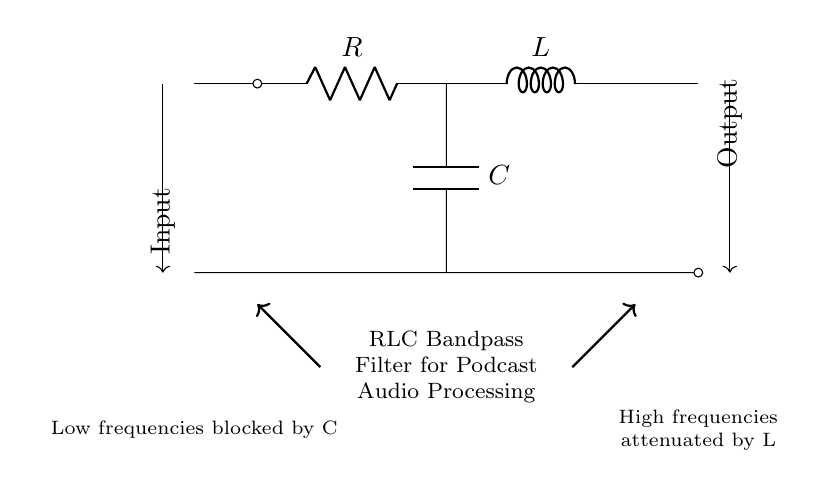What type of filter is represented in the circuit? The circuit diagram features an RLC bandpass filter, which is evident by the presence of a resistor, inductor, and capacitor connected in a specific arrangement designed to allow a certain range of frequencies to pass while attenuating others.
Answer: RLC bandpass filter What component blocks low frequencies? In the circuit, the capacitor is responsible for blocking low frequencies. Capacitors typically have lower impedance at higher frequencies, allowing them to pass higher frequency signals while filtering out lower frequencies.
Answer: Capacitor Which component is connected in series with the input? The resistor is the first component connected in series with the input as per the diagram direct connection from the input line leading into it.
Answer: Resistor What is the role of the inductor in this circuit? The inductor serves to attenuate high frequencies while allowing lower frequencies to pass. As frequency increases, the inductor’s impedance increases, thus blocking higher frequencies beyond the filter's passband.
Answer: Attenuate high frequencies How are the capacitor and the resistor connected? The capacitor is connected in parallel with the resistor in this circuit setup, as depicted in the diagram, where one terminal of the capacitor connects directly to the junction point with the resistor and the other terminal leads towards the ground, effectively creating a parallel path for one part of the circuit.
Answer: Parallel What happens to high frequencies in this circuit? High frequencies are attenuated by the inductor, which increases its impedance at higher frequencies, thereby restricting the passage of signals that are beyond the filter's designated frequency band.
Answer: Attenuated What is the output relationship to input in this filter? The output captures the frequencies that fall within the passband of the filter, which are neither too low (blocked by the capacitor) nor too high (attenuated by the inductor), showing that it is a selective filter allowing only specific audio frequencies to pass through.
Answer: Selective frequencies pass 